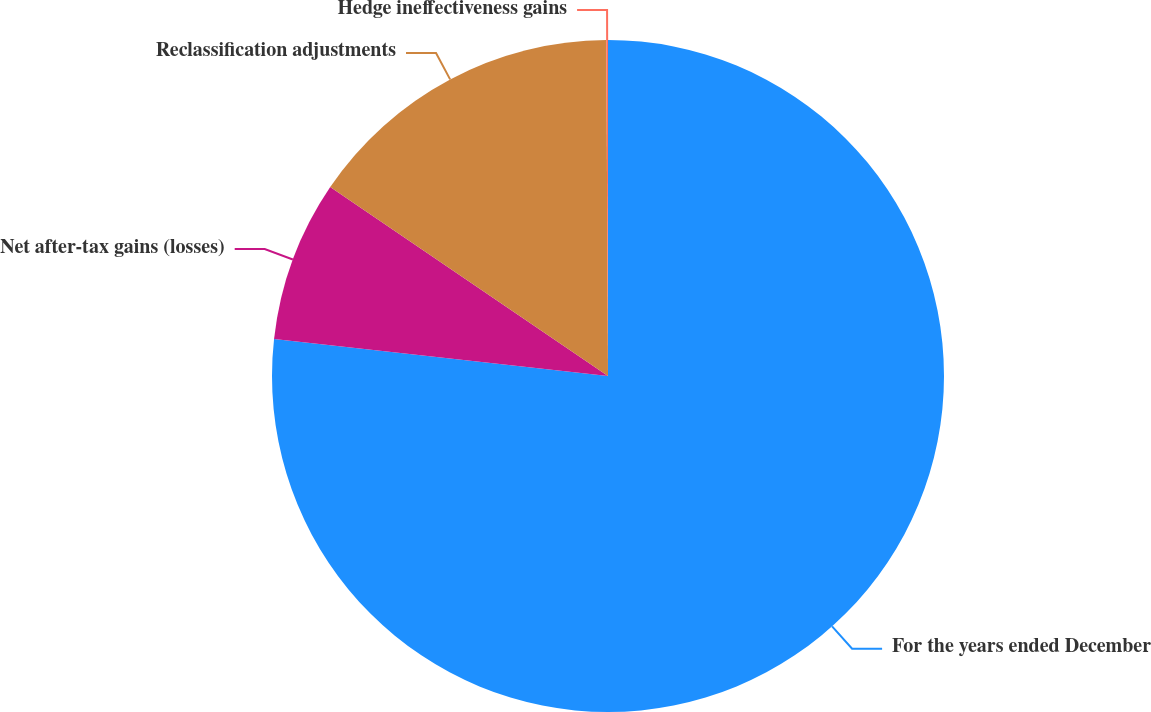Convert chart to OTSL. <chart><loc_0><loc_0><loc_500><loc_500><pie_chart><fcel>For the years ended December<fcel>Net after-tax gains (losses)<fcel>Reclassification adjustments<fcel>Hedge ineffectiveness gains<nl><fcel>76.76%<fcel>7.75%<fcel>15.41%<fcel>0.08%<nl></chart> 